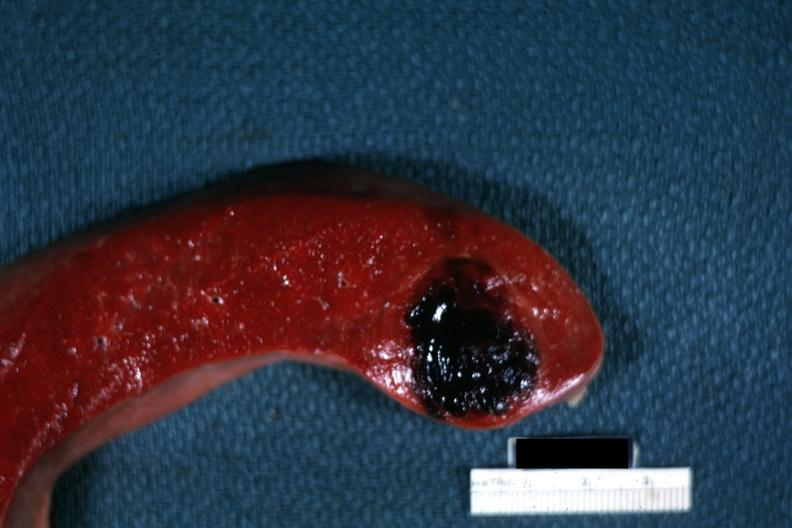where is this part in?
Answer the question using a single word or phrase. Spleen 